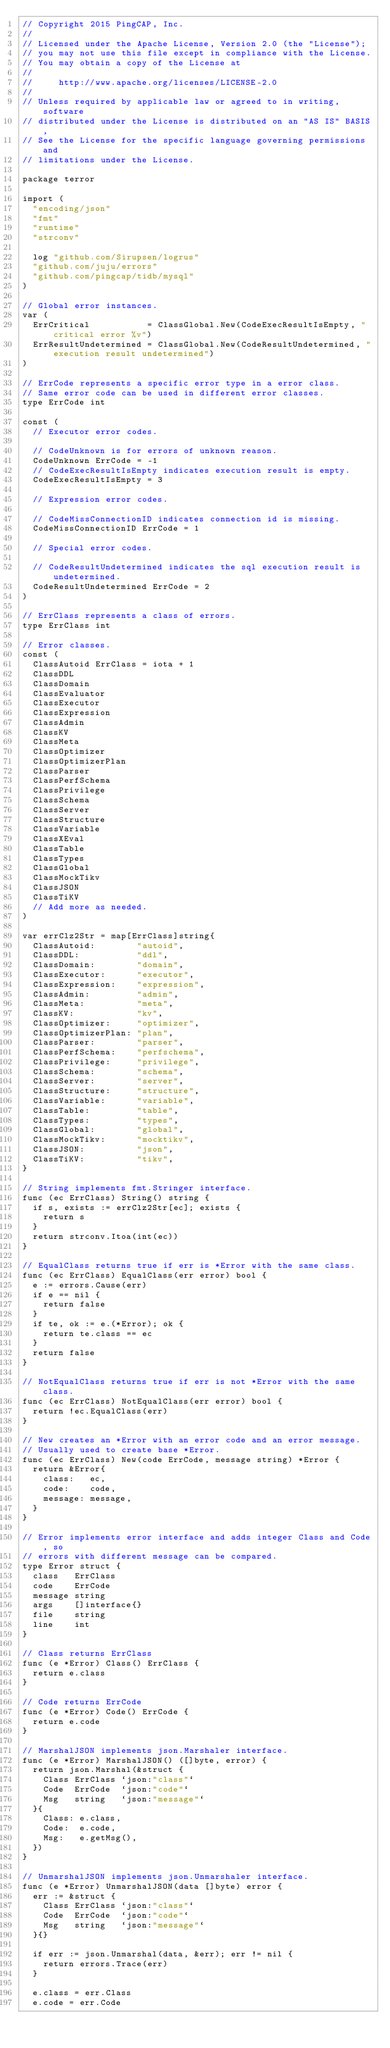Convert code to text. <code><loc_0><loc_0><loc_500><loc_500><_Go_>// Copyright 2015 PingCAP, Inc.
//
// Licensed under the Apache License, Version 2.0 (the "License");
// you may not use this file except in compliance with the License.
// You may obtain a copy of the License at
//
//     http://www.apache.org/licenses/LICENSE-2.0
//
// Unless required by applicable law or agreed to in writing, software
// distributed under the License is distributed on an "AS IS" BASIS,
// See the License for the specific language governing permissions and
// limitations under the License.

package terror

import (
	"encoding/json"
	"fmt"
	"runtime"
	"strconv"

	log "github.com/Sirupsen/logrus"
	"github.com/juju/errors"
	"github.com/pingcap/tidb/mysql"
)

// Global error instances.
var (
	ErrCritical           = ClassGlobal.New(CodeExecResultIsEmpty, "critical error %v")
	ErrResultUndetermined = ClassGlobal.New(CodeResultUndetermined, "execution result undetermined")
)

// ErrCode represents a specific error type in a error class.
// Same error code can be used in different error classes.
type ErrCode int

const (
	// Executor error codes.

	// CodeUnknown is for errors of unknown reason.
	CodeUnknown ErrCode = -1
	// CodeExecResultIsEmpty indicates execution result is empty.
	CodeExecResultIsEmpty = 3

	// Expression error codes.

	// CodeMissConnectionID indicates connection id is missing.
	CodeMissConnectionID ErrCode = 1

	// Special error codes.

	// CodeResultUndetermined indicates the sql execution result is undetermined.
	CodeResultUndetermined ErrCode = 2
)

// ErrClass represents a class of errors.
type ErrClass int

// Error classes.
const (
	ClassAutoid ErrClass = iota + 1
	ClassDDL
	ClassDomain
	ClassEvaluator
	ClassExecutor
	ClassExpression
	ClassAdmin
	ClassKV
	ClassMeta
	ClassOptimizer
	ClassOptimizerPlan
	ClassParser
	ClassPerfSchema
	ClassPrivilege
	ClassSchema
	ClassServer
	ClassStructure
	ClassVariable
	ClassXEval
	ClassTable
	ClassTypes
	ClassGlobal
	ClassMockTikv
	ClassJSON
	ClassTiKV
	// Add more as needed.
)

var errClz2Str = map[ErrClass]string{
	ClassAutoid:        "autoid",
	ClassDDL:           "ddl",
	ClassDomain:        "domain",
	ClassExecutor:      "executor",
	ClassExpression:    "expression",
	ClassAdmin:         "admin",
	ClassMeta:          "meta",
	ClassKV:            "kv",
	ClassOptimizer:     "optimizer",
	ClassOptimizerPlan: "plan",
	ClassParser:        "parser",
	ClassPerfSchema:    "perfschema",
	ClassPrivilege:     "privilege",
	ClassSchema:        "schema",
	ClassServer:        "server",
	ClassStructure:     "structure",
	ClassVariable:      "variable",
	ClassTable:         "table",
	ClassTypes:         "types",
	ClassGlobal:        "global",
	ClassMockTikv:      "mocktikv",
	ClassJSON:          "json",
	ClassTiKV:          "tikv",
}

// String implements fmt.Stringer interface.
func (ec ErrClass) String() string {
	if s, exists := errClz2Str[ec]; exists {
		return s
	}
	return strconv.Itoa(int(ec))
}

// EqualClass returns true if err is *Error with the same class.
func (ec ErrClass) EqualClass(err error) bool {
	e := errors.Cause(err)
	if e == nil {
		return false
	}
	if te, ok := e.(*Error); ok {
		return te.class == ec
	}
	return false
}

// NotEqualClass returns true if err is not *Error with the same class.
func (ec ErrClass) NotEqualClass(err error) bool {
	return !ec.EqualClass(err)
}

// New creates an *Error with an error code and an error message.
// Usually used to create base *Error.
func (ec ErrClass) New(code ErrCode, message string) *Error {
	return &Error{
		class:   ec,
		code:    code,
		message: message,
	}
}

// Error implements error interface and adds integer Class and Code, so
// errors with different message can be compared.
type Error struct {
	class   ErrClass
	code    ErrCode
	message string
	args    []interface{}
	file    string
	line    int
}

// Class returns ErrClass
func (e *Error) Class() ErrClass {
	return e.class
}

// Code returns ErrCode
func (e *Error) Code() ErrCode {
	return e.code
}

// MarshalJSON implements json.Marshaler interface.
func (e *Error) MarshalJSON() ([]byte, error) {
	return json.Marshal(&struct {
		Class ErrClass `json:"class"`
		Code  ErrCode  `json:"code"`
		Msg   string   `json:"message"`
	}{
		Class: e.class,
		Code:  e.code,
		Msg:   e.getMsg(),
	})
}

// UnmarshalJSON implements json.Unmarshaler interface.
func (e *Error) UnmarshalJSON(data []byte) error {
	err := &struct {
		Class ErrClass `json:"class"`
		Code  ErrCode  `json:"code"`
		Msg   string   `json:"message"`
	}{}

	if err := json.Unmarshal(data, &err); err != nil {
		return errors.Trace(err)
	}

	e.class = err.Class
	e.code = err.Code</code> 